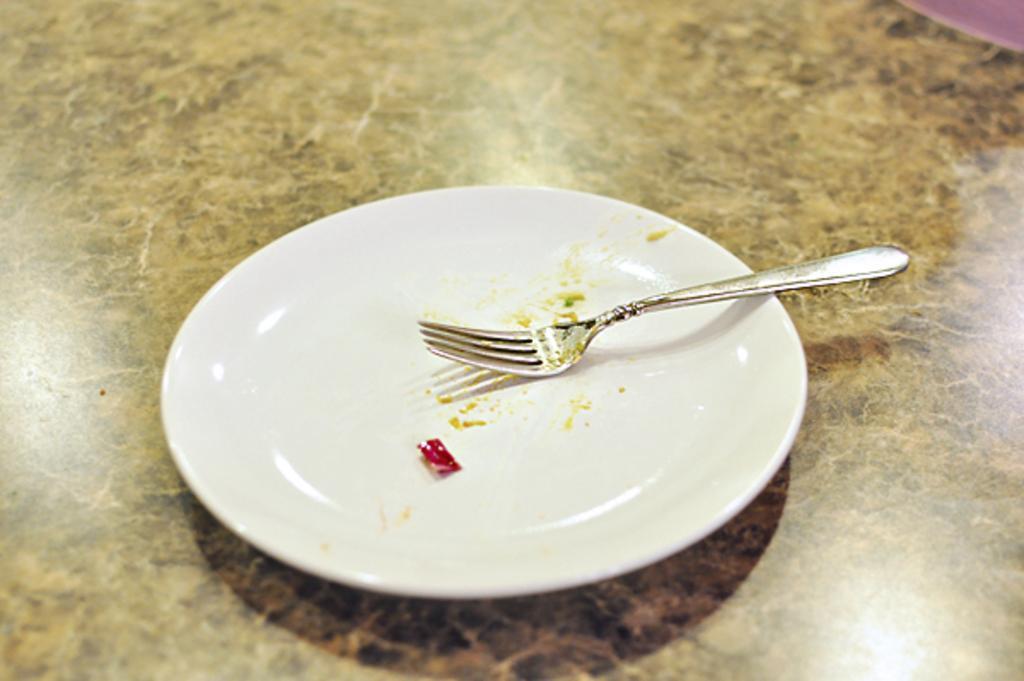Can you describe this image briefly? In this picture we can observe a white color plate. There is a fork placed in the plate. The plate is placed on the brown color surface. 